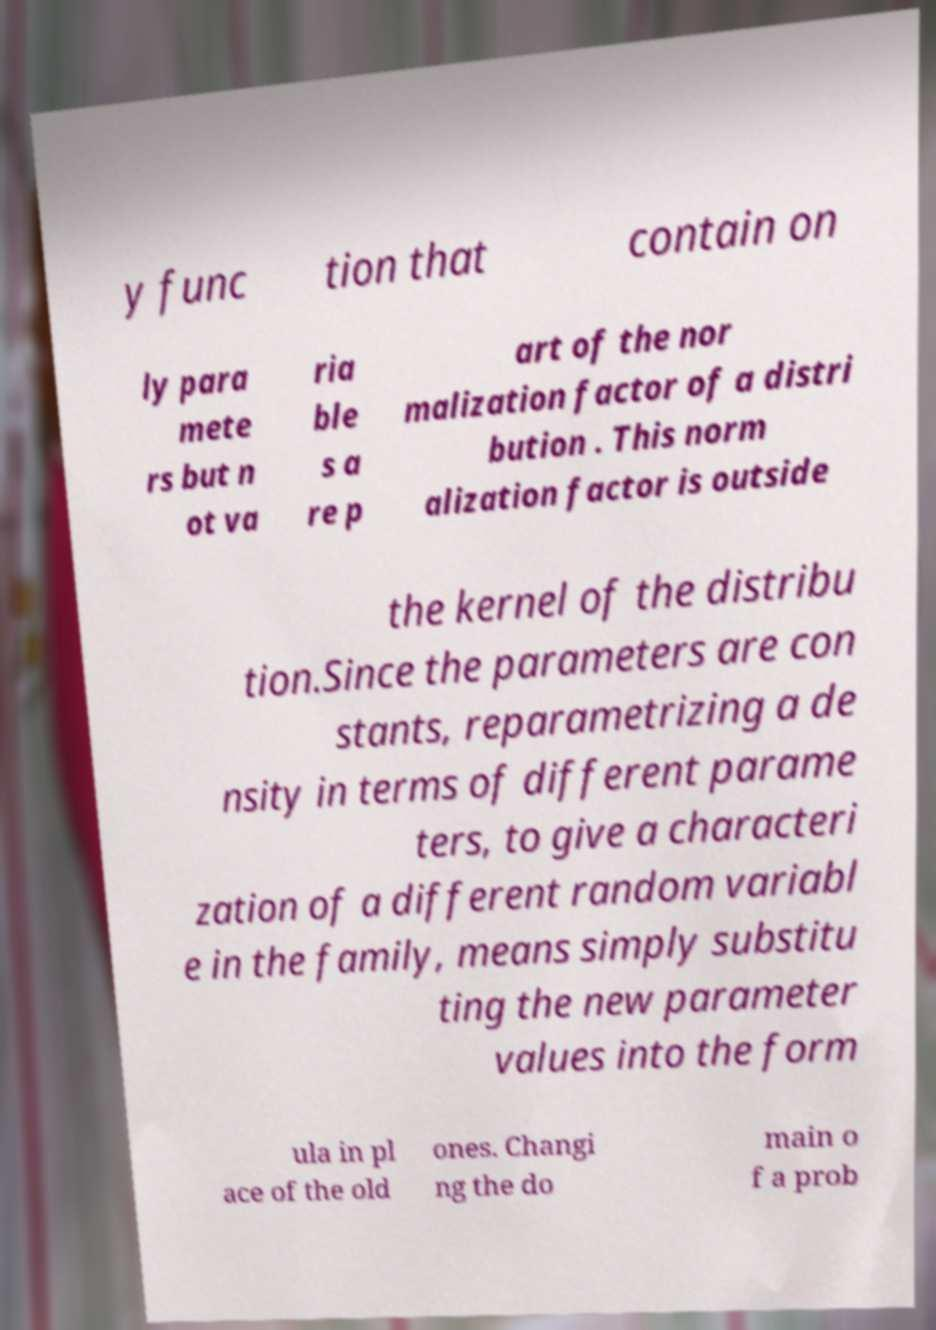Could you assist in decoding the text presented in this image and type it out clearly? y func tion that contain on ly para mete rs but n ot va ria ble s a re p art of the nor malization factor of a distri bution . This norm alization factor is outside the kernel of the distribu tion.Since the parameters are con stants, reparametrizing a de nsity in terms of different parame ters, to give a characteri zation of a different random variabl e in the family, means simply substitu ting the new parameter values into the form ula in pl ace of the old ones. Changi ng the do main o f a prob 